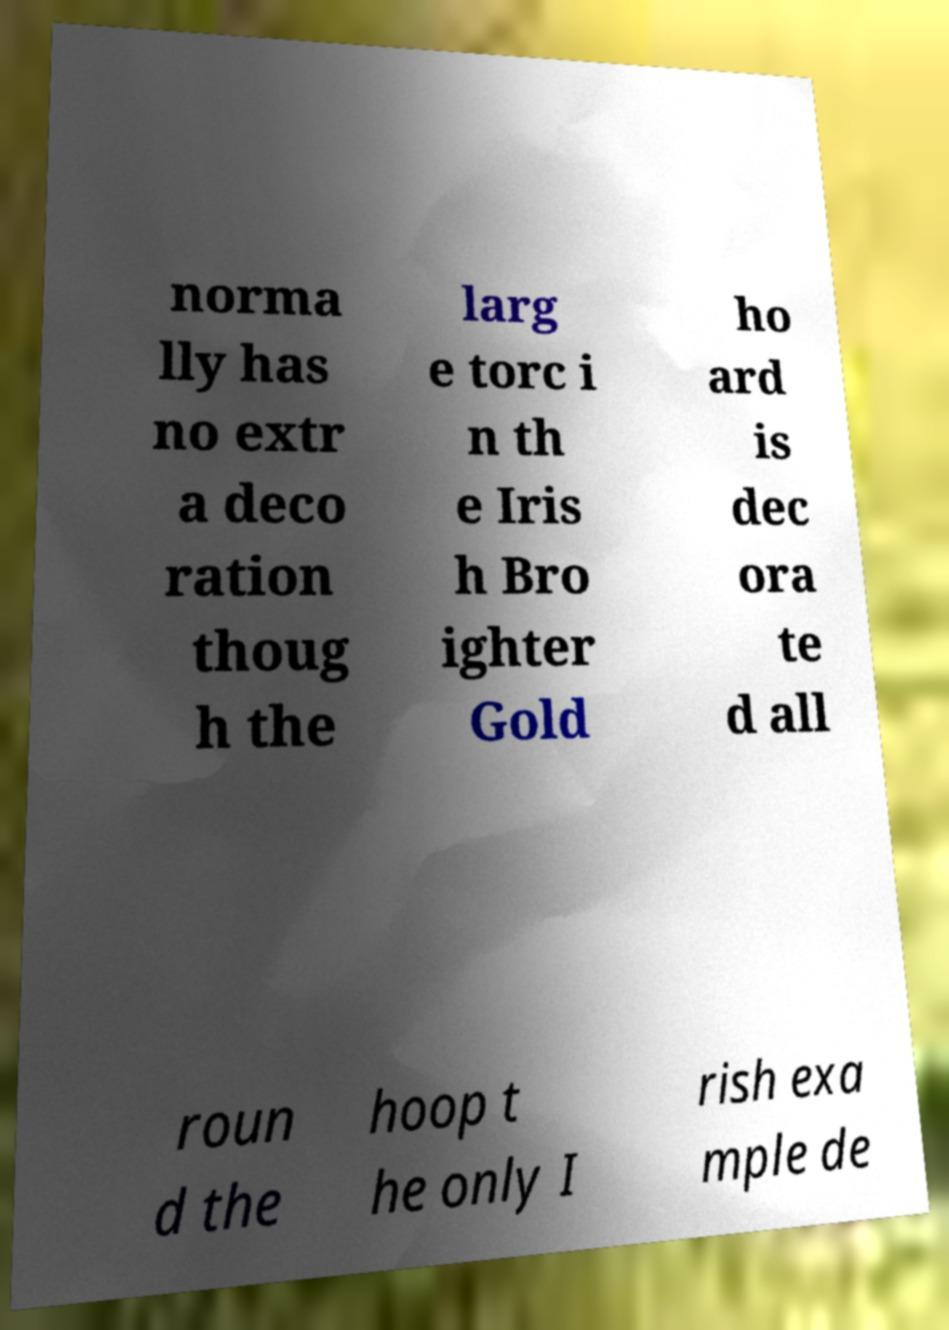Please read and relay the text visible in this image. What does it say? norma lly has no extr a deco ration thoug h the larg e torc i n th e Iris h Bro ighter Gold ho ard is dec ora te d all roun d the hoop t he only I rish exa mple de 